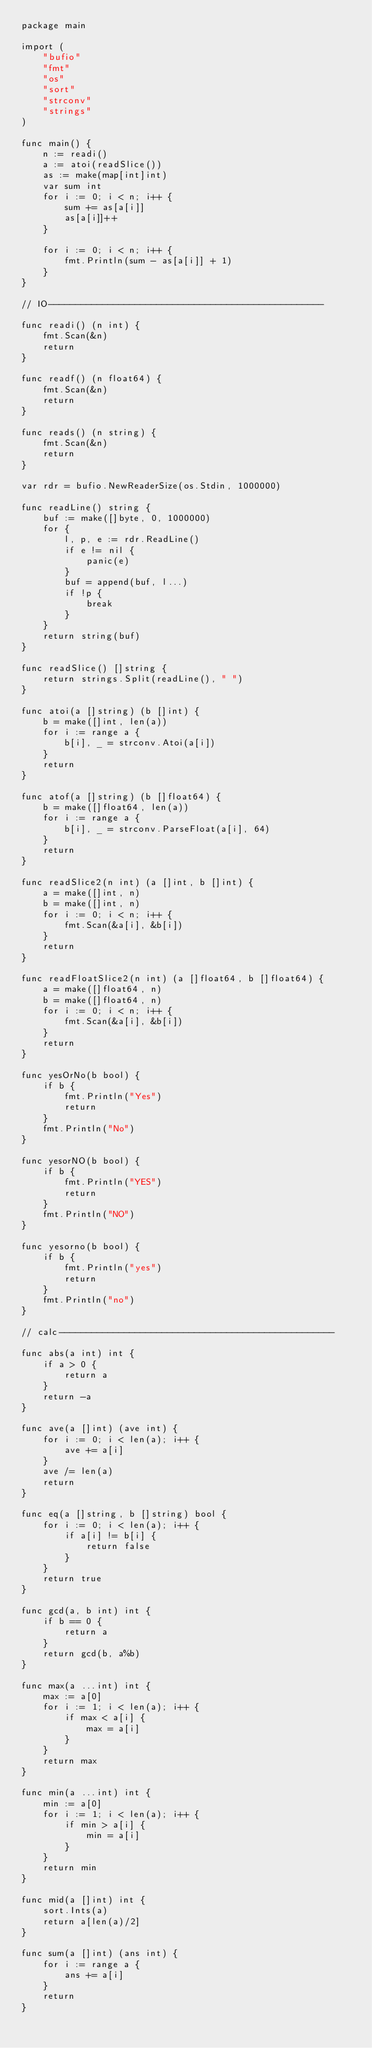<code> <loc_0><loc_0><loc_500><loc_500><_Go_>package main

import (
	"bufio"
	"fmt"
	"os"
	"sort"
	"strconv"
	"strings"
)

func main() {
	n := readi()
	a := atoi(readSlice())
	as := make(map[int]int)
	var sum int
	for i := 0; i < n; i++ {
		sum += as[a[i]]
		as[a[i]]++
	}

	for i := 0; i < n; i++ {
		fmt.Println(sum - as[a[i]] + 1)
	}
}

// IO---------------------------------------------------

func readi() (n int) {
	fmt.Scan(&n)
	return
}

func readf() (n float64) {
	fmt.Scan(&n)
	return
}

func reads() (n string) {
	fmt.Scan(&n)
	return
}

var rdr = bufio.NewReaderSize(os.Stdin, 1000000)

func readLine() string {
	buf := make([]byte, 0, 1000000)
	for {
		l, p, e := rdr.ReadLine()
		if e != nil {
			panic(e)
		}
		buf = append(buf, l...)
		if !p {
			break
		}
	}
	return string(buf)
}

func readSlice() []string {
	return strings.Split(readLine(), " ")
}

func atoi(a []string) (b []int) {
	b = make([]int, len(a))
	for i := range a {
		b[i], _ = strconv.Atoi(a[i])
	}
	return
}

func atof(a []string) (b []float64) {
	b = make([]float64, len(a))
	for i := range a {
		b[i], _ = strconv.ParseFloat(a[i], 64)
	}
	return
}

func readSlice2(n int) (a []int, b []int) {
	a = make([]int, n)
	b = make([]int, n)
	for i := 0; i < n; i++ {
		fmt.Scan(&a[i], &b[i])
	}
	return
}

func readFloatSlice2(n int) (a []float64, b []float64) {
	a = make([]float64, n)
	b = make([]float64, n)
	for i := 0; i < n; i++ {
		fmt.Scan(&a[i], &b[i])
	}
	return
}

func yesOrNo(b bool) {
	if b {
		fmt.Println("Yes")
		return
	}
	fmt.Println("No")
}

func yesorNO(b bool) {
	if b {
		fmt.Println("YES")
		return
	}
	fmt.Println("NO")
}

func yesorno(b bool) {
	if b {
		fmt.Println("yes")
		return
	}
	fmt.Println("no")
}

// calc---------------------------------------------------

func abs(a int) int {
	if a > 0 {
		return a
	}
	return -a
}

func ave(a []int) (ave int) {
	for i := 0; i < len(a); i++ {
		ave += a[i]
	}
	ave /= len(a)
	return
}

func eq(a []string, b []string) bool {
	for i := 0; i < len(a); i++ {
		if a[i] != b[i] {
			return false
		}
	}
	return true
}

func gcd(a, b int) int {
	if b == 0 {
		return a
	}
	return gcd(b, a%b)
}

func max(a ...int) int {
	max := a[0]
	for i := 1; i < len(a); i++ {
		if max < a[i] {
			max = a[i]
		}
	}
	return max
}

func min(a ...int) int {
	min := a[0]
	for i := 1; i < len(a); i++ {
		if min > a[i] {
			min = a[i]
		}
	}
	return min
}

func mid(a []int) int {
	sort.Ints(a)
	return a[len(a)/2]
}

func sum(a []int) (ans int) {
	for i := range a {
		ans += a[i]
	}
	return
}
</code> 